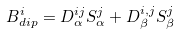<formula> <loc_0><loc_0><loc_500><loc_500>B ^ { i } _ { d i p } = D _ { \alpha } ^ { i j } S _ { \alpha } ^ { j } + D _ { \beta } ^ { i , j } S _ { \beta } ^ { j }</formula> 